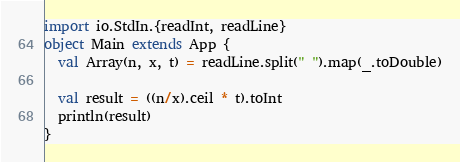<code> <loc_0><loc_0><loc_500><loc_500><_Scala_>import io.StdIn.{readInt, readLine}
object Main extends App {
  val Array(n, x, t) = readLine.split(" ").map(_.toDouble)

  val result = ((n/x).ceil * t).toInt
  println(result)
}</code> 